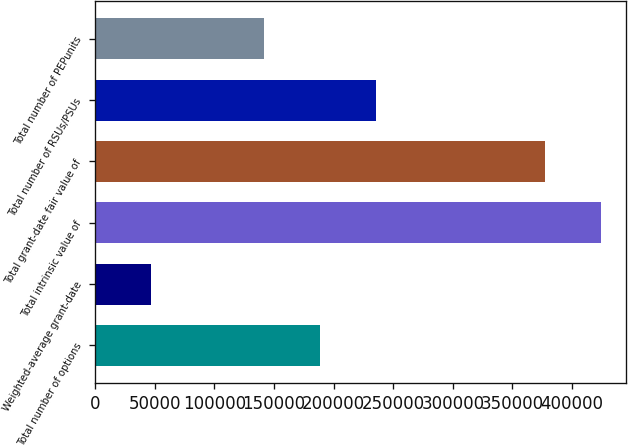Convert chart to OTSL. <chart><loc_0><loc_0><loc_500><loc_500><bar_chart><fcel>Total number of options<fcel>Weighted-average grant-date<fcel>Total intrinsic value of<fcel>Total grant-date fair value of<fcel>Total number of RSUs/PSUs<fcel>Total number of PEPunits<nl><fcel>188595<fcel>47154.8<fcel>424328<fcel>377182<fcel>235742<fcel>141448<nl></chart> 